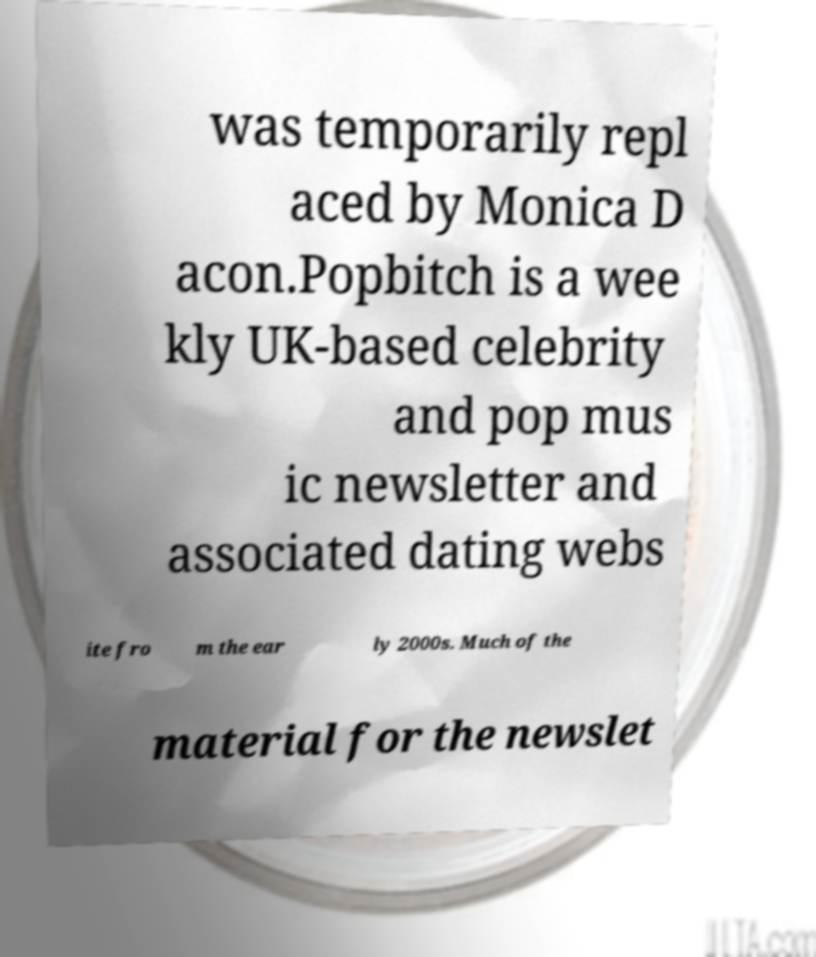For documentation purposes, I need the text within this image transcribed. Could you provide that? was temporarily repl aced by Monica D acon.Popbitch is a wee kly UK-based celebrity and pop mus ic newsletter and associated dating webs ite fro m the ear ly 2000s. Much of the material for the newslet 